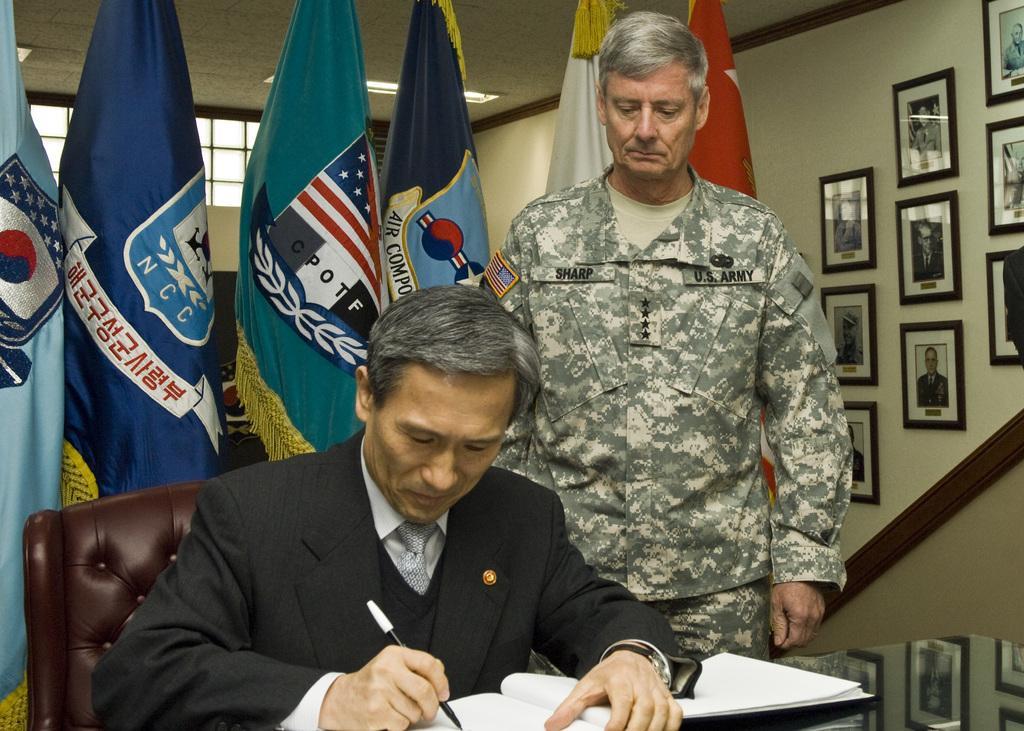Could you give a brief overview of what you see in this image? In this image I can see two men where one is sitting on a chair and another one is standing. I can also see he is wearing a uniform. In the background I can see few flags and few frames on this wall. Here I can see he is holding a pen and a book. 